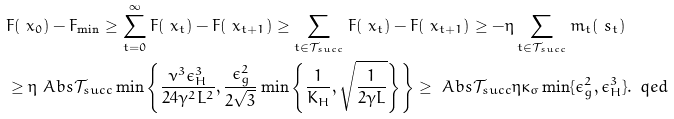<formula> <loc_0><loc_0><loc_500><loc_500>& F ( \ x _ { 0 } ) - F _ { \min } \geq \sum _ { t = 0 } ^ { \infty } F ( \ x _ { t } ) - F ( \ x _ { t + 1 } ) \geq \sum _ { t \in \mathcal { T } _ { s u c c } } F ( \ x _ { t } ) - F ( \ x _ { t + 1 } ) \geq - \eta \sum _ { t \in \mathcal { T } _ { s u c c } } m _ { t } ( \ s _ { t } ) \\ & \geq \eta \ A b s { \mathcal { T } _ { s u c c } } \min \left \{ \frac { \nu ^ { 3 } \epsilon _ { H } ^ { 3 } } { 2 4 \gamma ^ { 2 } L ^ { 2 } } , \frac { \epsilon _ { g } ^ { 2 } } { 2 \sqrt { 3 } } \min \left \{ \frac { 1 } { K _ { H } } , \sqrt { \frac { 1 } { 2 \gamma L } } \right \} \right \} \geq \ A b s { \mathcal { T } _ { s u c c } } \eta \kappa _ { \sigma } \min \{ \epsilon _ { g } ^ { 2 } , \epsilon _ { H } ^ { 3 } \} . \, \ q e d</formula> 